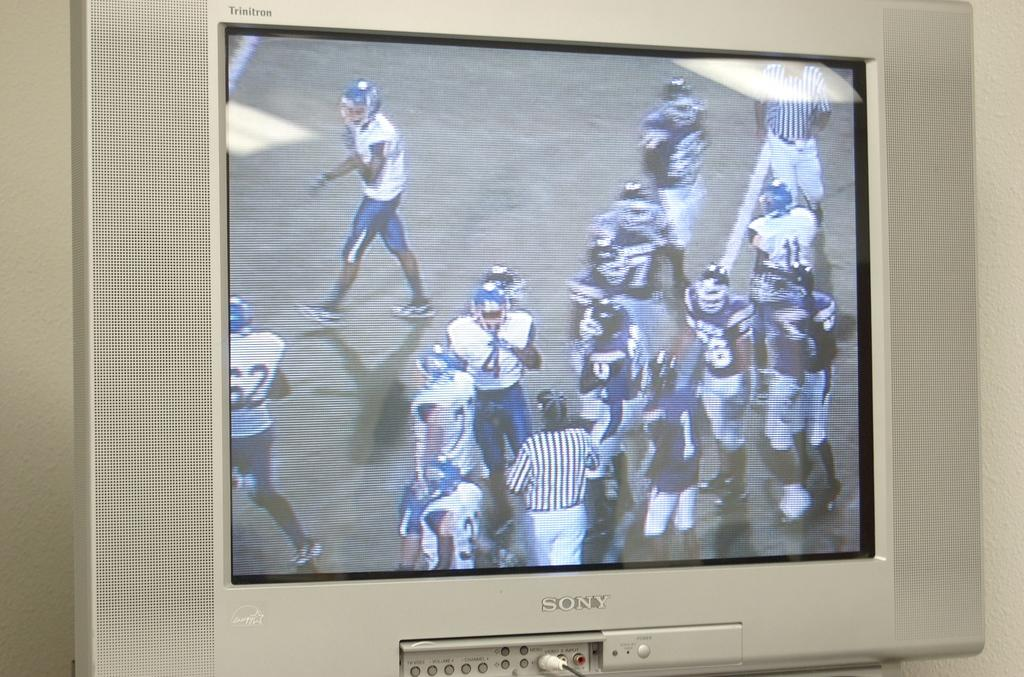<image>
Relay a brief, clear account of the picture shown. A Sony TV shows a bunch of Football players on the field next to a referee. 